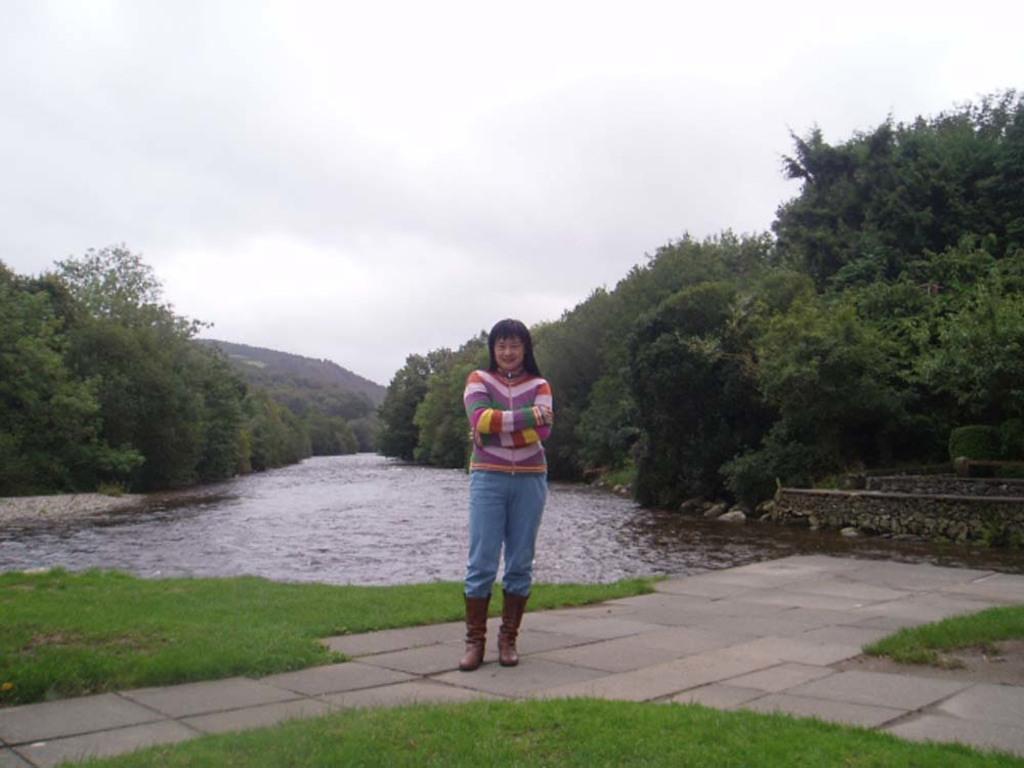How would you summarize this image in a sentence or two? In the image we can see there is a woman standing on the ground and the ground is covered with grass and stone tiles. Behind there is water and there are trees on both the sides. There is clear sky on the top. 